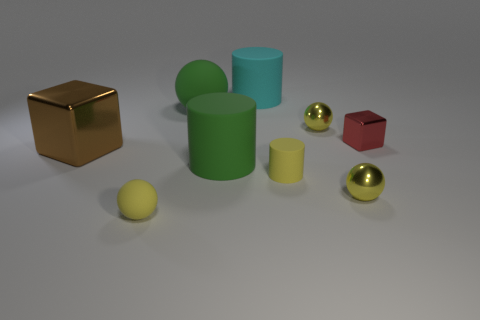There is a cylinder that is the same color as the large matte sphere; what size is it?
Your answer should be very brief. Large. What number of large cylinders are the same color as the big ball?
Give a very brief answer. 1. There is a cube to the left of the big green ball; how many big cylinders are behind it?
Make the answer very short. 1. There is a cube that is on the left side of the red block; is its color the same as the metallic sphere that is behind the large brown metal cube?
Offer a terse response. No. What shape is the rubber thing that is to the right of the large green cylinder and behind the red metallic object?
Provide a short and direct response. Cylinder. Are there any cyan matte objects of the same shape as the red object?
Your response must be concise. No. What shape is the metal thing that is the same size as the green cylinder?
Your response must be concise. Cube. What is the big green cylinder made of?
Give a very brief answer. Rubber. There is a matte ball that is right of the yellow thing that is in front of the tiny metallic ball in front of the brown cube; what is its size?
Your response must be concise. Large. How many metallic objects are large green balls or tiny brown balls?
Offer a very short reply. 0. 